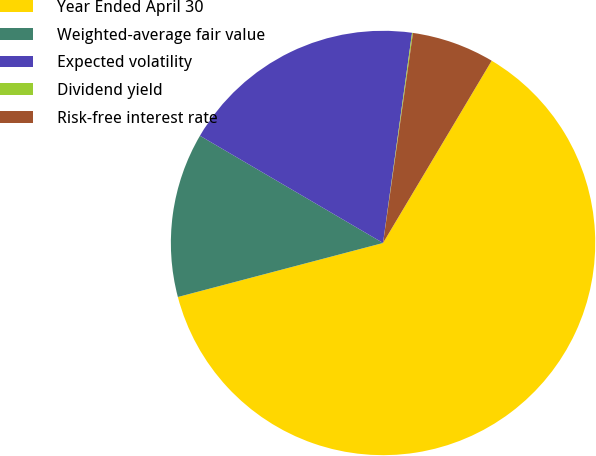Convert chart. <chart><loc_0><loc_0><loc_500><loc_500><pie_chart><fcel>Year Ended April 30<fcel>Weighted-average fair value<fcel>Expected volatility<fcel>Dividend yield<fcel>Risk-free interest rate<nl><fcel>62.35%<fcel>12.53%<fcel>18.75%<fcel>0.07%<fcel>6.3%<nl></chart> 